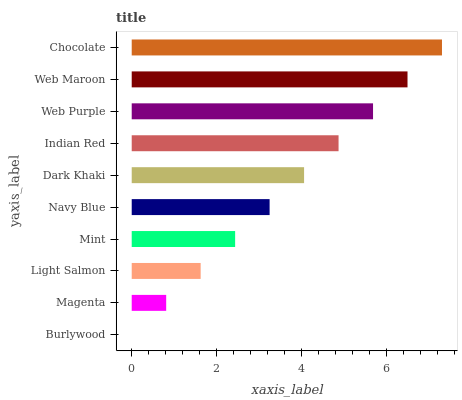Is Burlywood the minimum?
Answer yes or no. Yes. Is Chocolate the maximum?
Answer yes or no. Yes. Is Magenta the minimum?
Answer yes or no. No. Is Magenta the maximum?
Answer yes or no. No. Is Magenta greater than Burlywood?
Answer yes or no. Yes. Is Burlywood less than Magenta?
Answer yes or no. Yes. Is Burlywood greater than Magenta?
Answer yes or no. No. Is Magenta less than Burlywood?
Answer yes or no. No. Is Dark Khaki the high median?
Answer yes or no. Yes. Is Navy Blue the low median?
Answer yes or no. Yes. Is Light Salmon the high median?
Answer yes or no. No. Is Chocolate the low median?
Answer yes or no. No. 